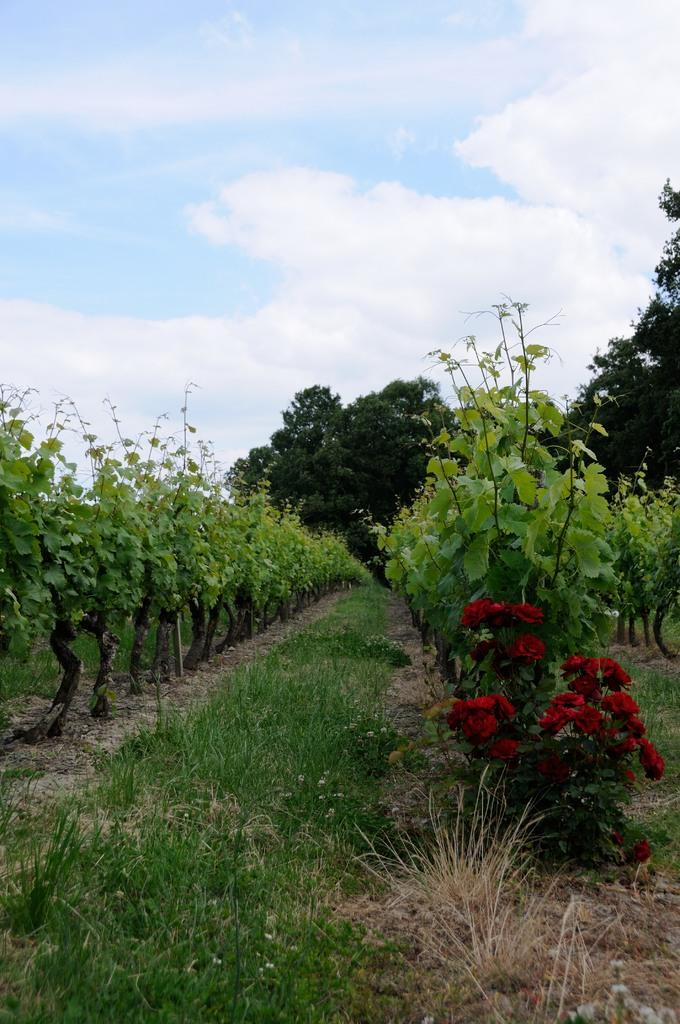What type of living organisms can be seen in the image? Plants and rose flowers are visible in the image. What other types of plants can be seen in the image? There are trees in the image. What is visible in the background of the image? The sky is visible in the image. What type of cork can be seen floating in the water in the image? There is no water or cork present in the image; it features plants, rose flowers, trees, and the sky. 